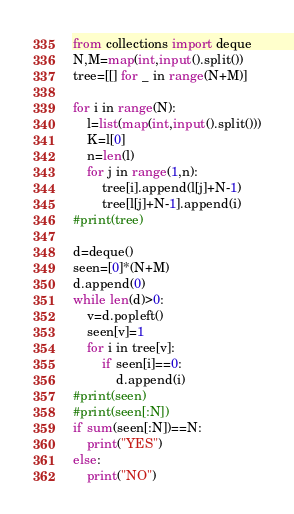<code> <loc_0><loc_0><loc_500><loc_500><_Python_>from collections import deque
N,M=map(int,input().split())
tree=[[] for _ in range(N+M)]

for i in range(N):
    l=list(map(int,input().split()))
    K=l[0]
    n=len(l)
    for j in range(1,n):
        tree[i].append(l[j]+N-1)
        tree[l[j]+N-1].append(i)
#print(tree)

d=deque()
seen=[0]*(N+M)
d.append(0)
while len(d)>0:
    v=d.popleft()
    seen[v]=1
    for i in tree[v]:
        if seen[i]==0:
            d.append(i)
#print(seen)
#print(seen[:N])
if sum(seen[:N])==N:
    print("YES")
else:
    print("NO")</code> 